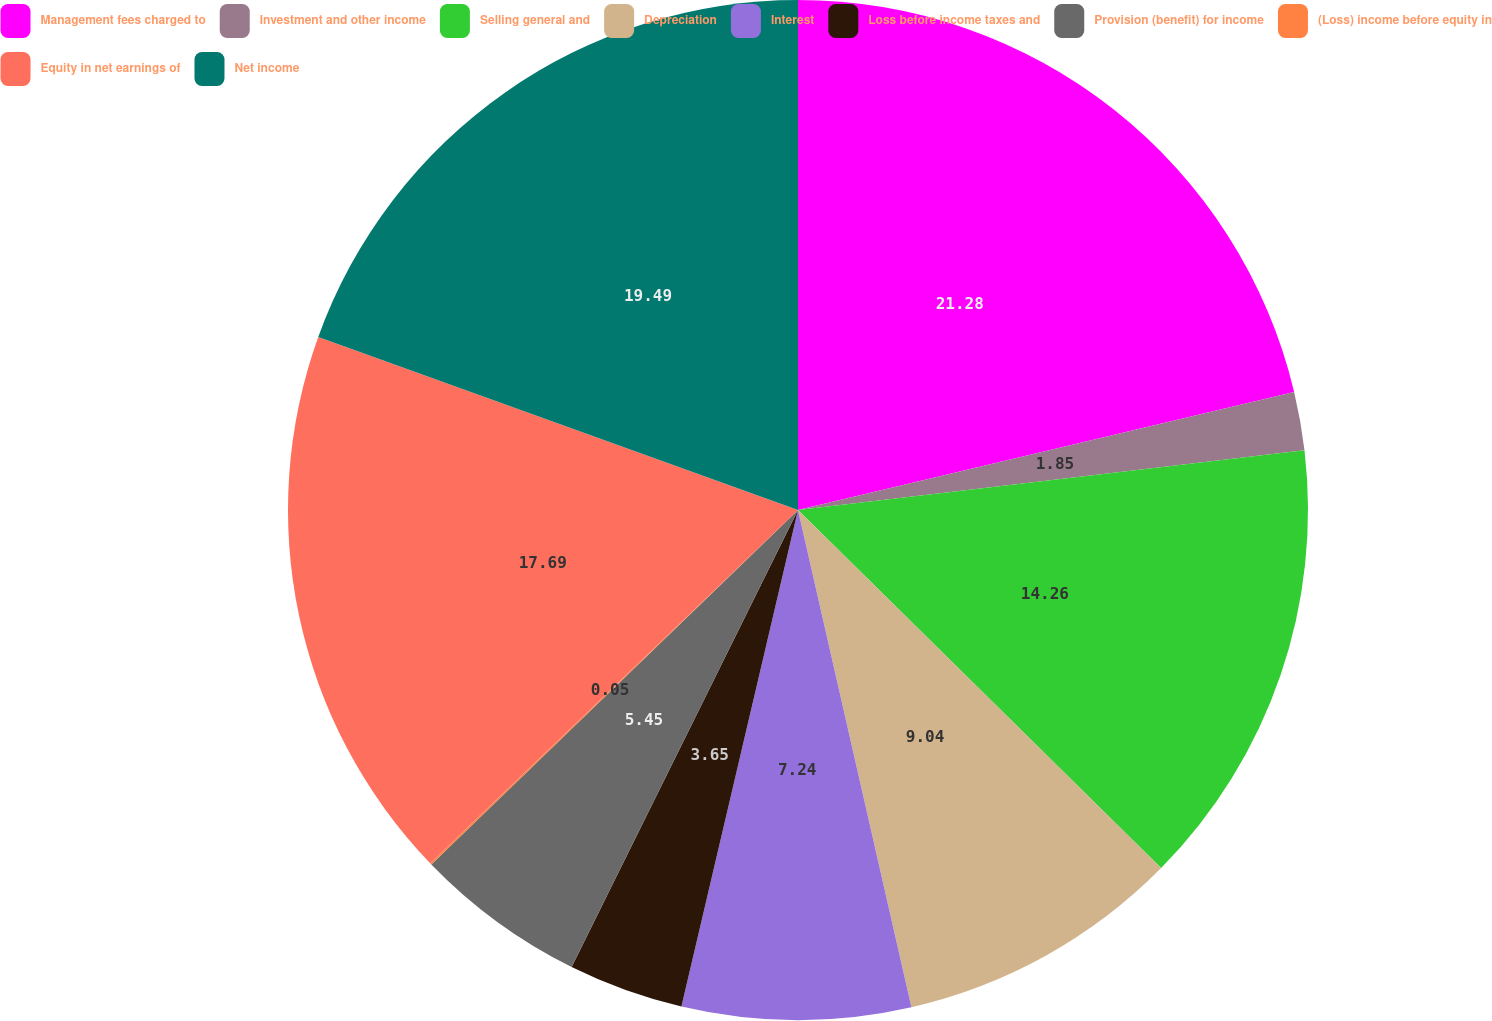<chart> <loc_0><loc_0><loc_500><loc_500><pie_chart><fcel>Management fees charged to<fcel>Investment and other income<fcel>Selling general and<fcel>Depreciation<fcel>Interest<fcel>Loss before income taxes and<fcel>Provision (benefit) for income<fcel>(Loss) income before equity in<fcel>Equity in net earnings of<fcel>Net income<nl><fcel>21.28%<fcel>1.85%<fcel>14.26%<fcel>9.04%<fcel>7.24%<fcel>3.65%<fcel>5.45%<fcel>0.05%<fcel>17.69%<fcel>19.49%<nl></chart> 